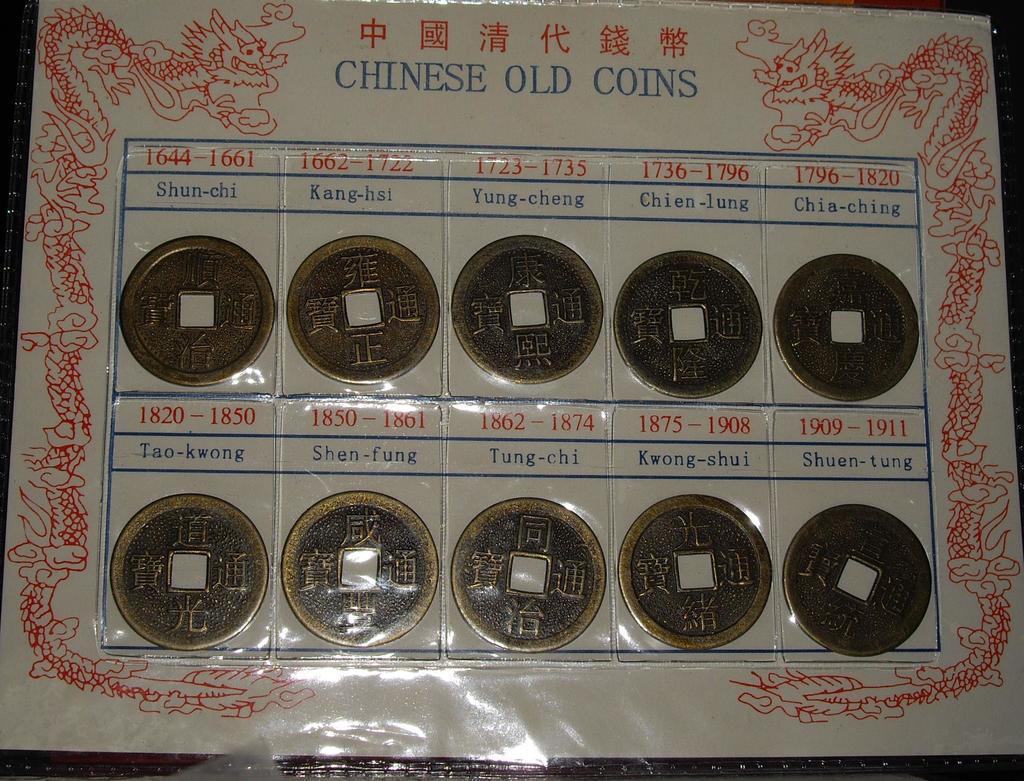<image>
Render a clear and concise summary of the photo. A display of Chinese Old Coins wrapped in plastic 